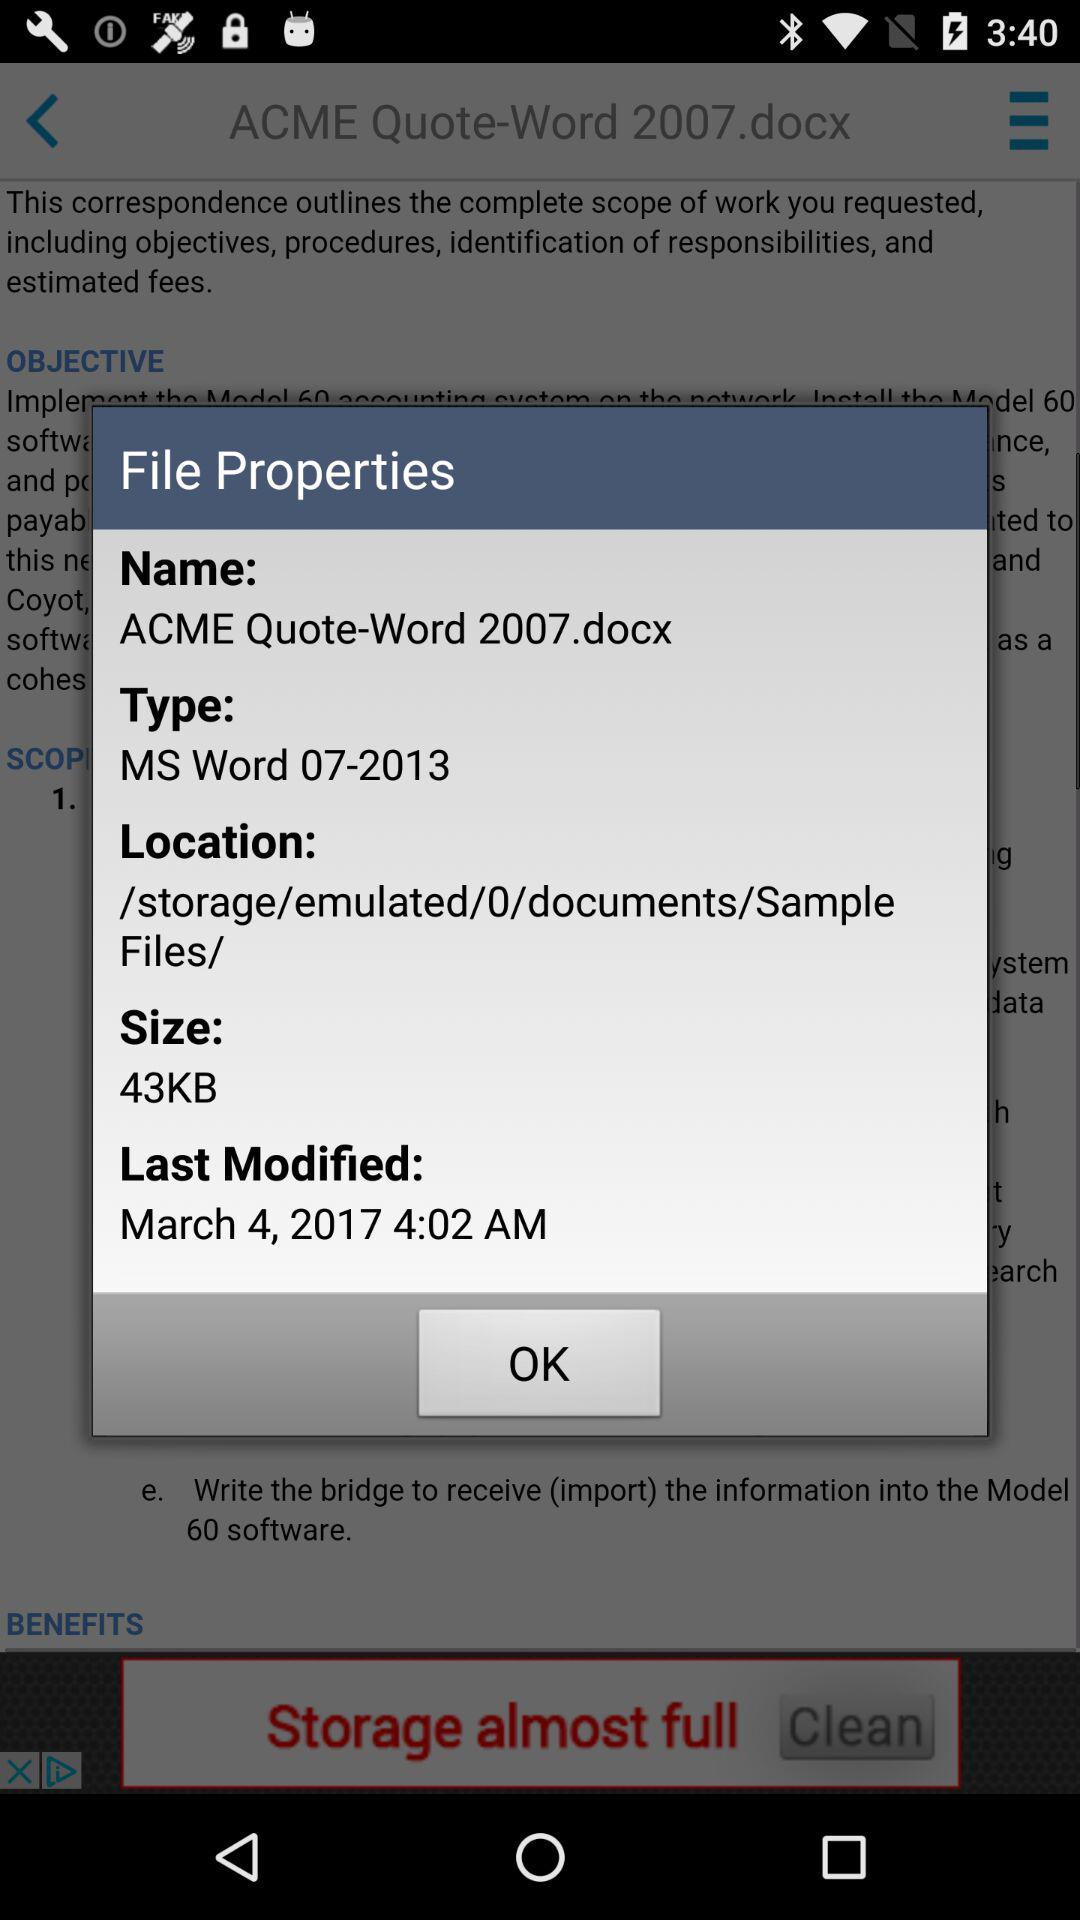What is the size? The size is 43KB. 